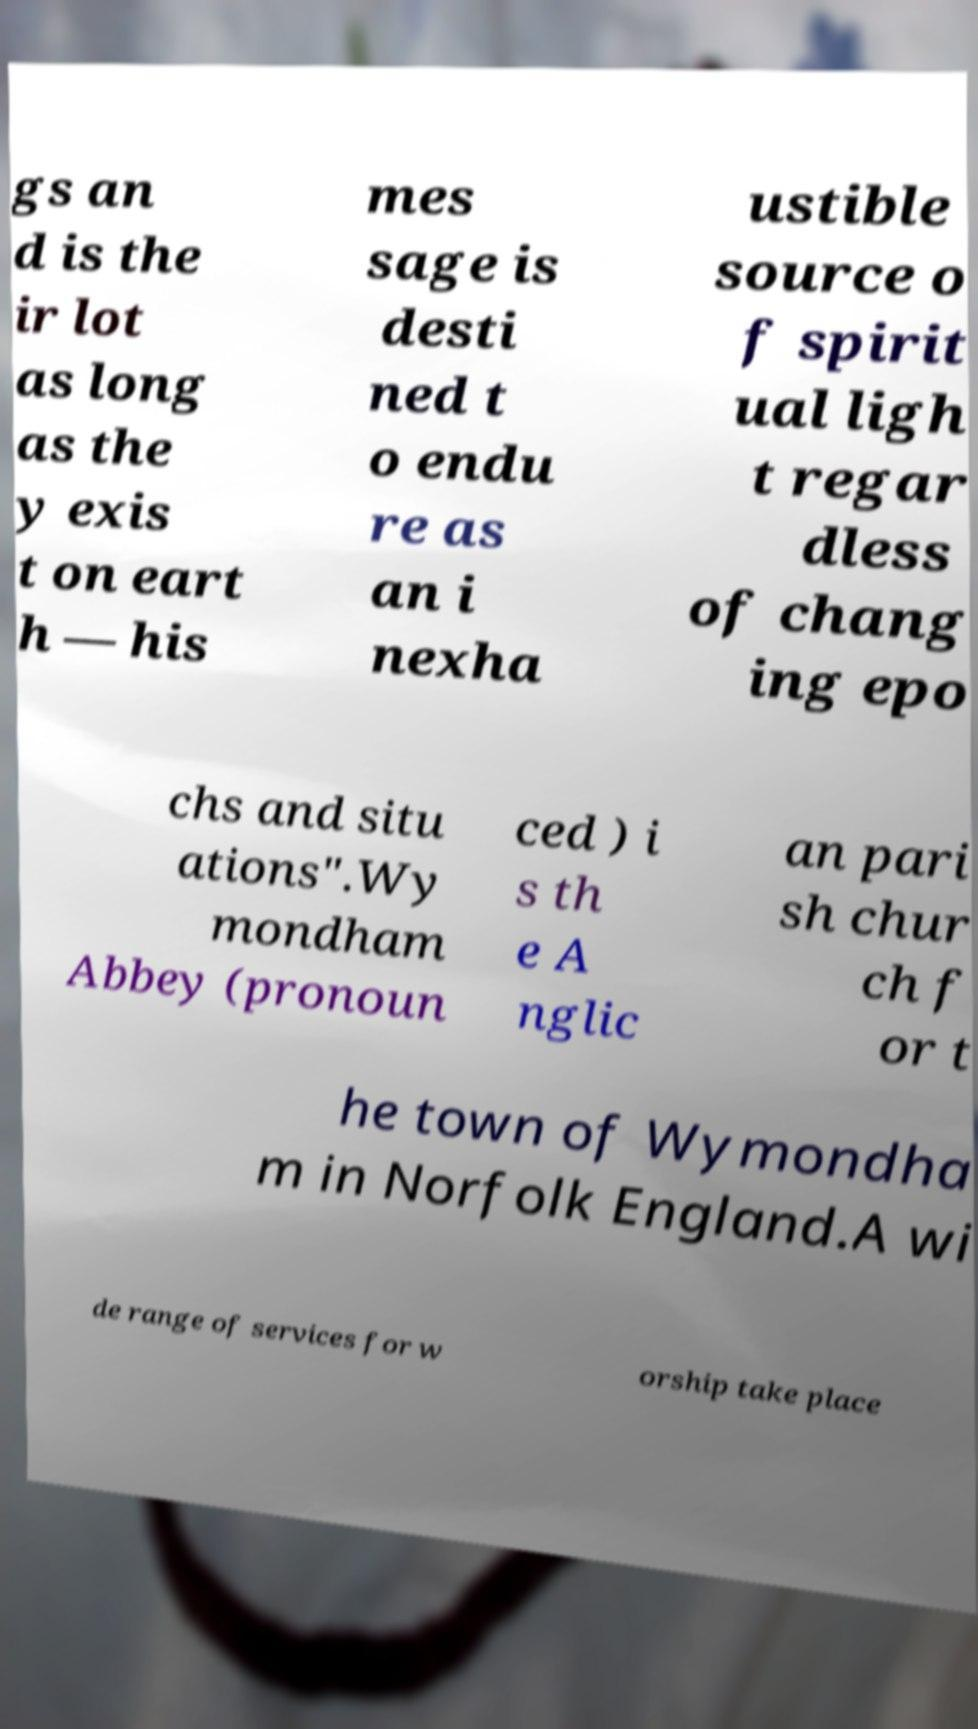There's text embedded in this image that I need extracted. Can you transcribe it verbatim? gs an d is the ir lot as long as the y exis t on eart h — his mes sage is desti ned t o endu re as an i nexha ustible source o f spirit ual ligh t regar dless of chang ing epo chs and situ ations".Wy mondham Abbey (pronoun ced ) i s th e A nglic an pari sh chur ch f or t he town of Wymondha m in Norfolk England.A wi de range of services for w orship take place 